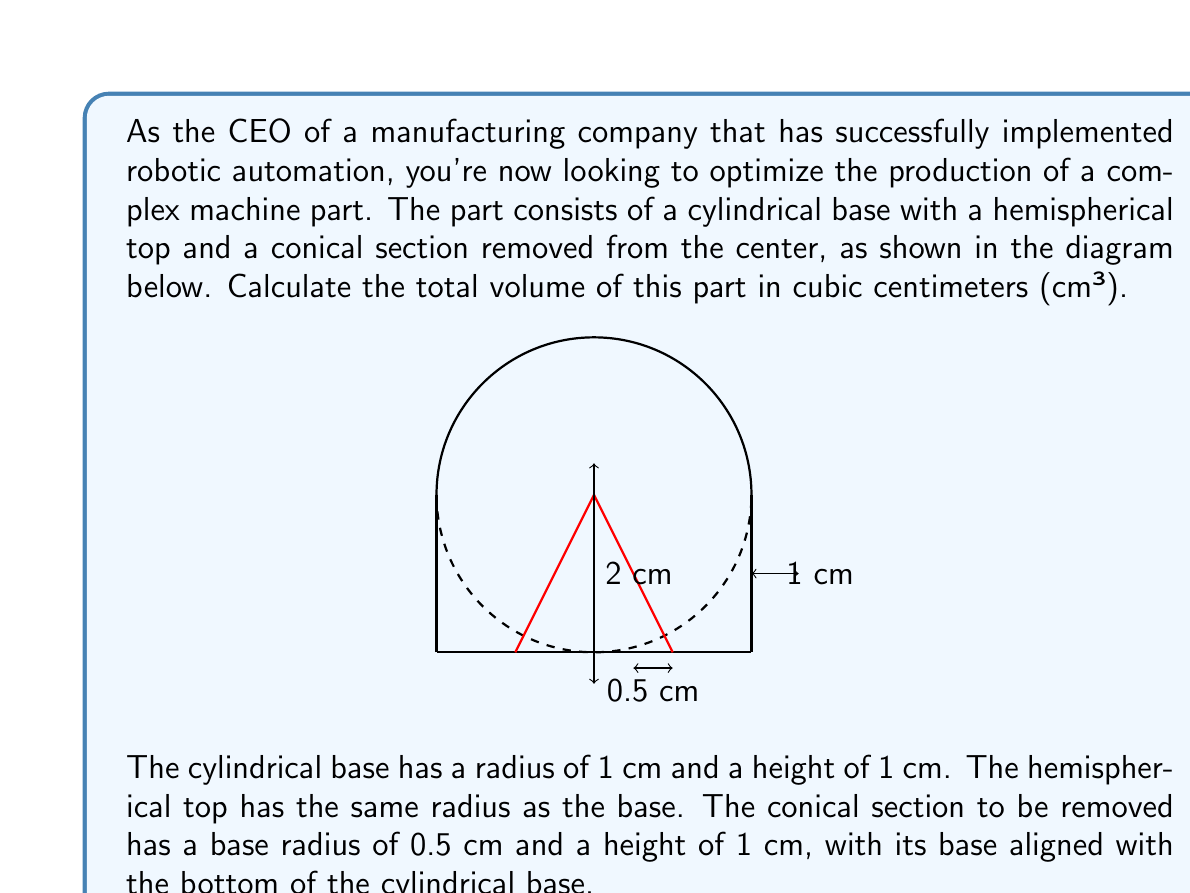Can you solve this math problem? Let's break this down step-by-step:

1) Volume of the cylindrical base:
   $$V_{cylinder} = \pi r^2 h = \pi \cdot 1^2 \cdot 1 = \pi \text{ cm}³$$

2) Volume of the hemispherical top:
   $$V_{hemisphere} = \frac{2}{3}\pi r^3 = \frac{2}{3}\pi \cdot 1^3 = \frac{2}{3}\pi \text{ cm}³$$

3) Volume of the conical section to be removed:
   $$V_{cone} = \frac{1}{3}\pi r^2 h = \frac{1}{3}\pi \cdot 0.5^2 \cdot 1 = \frac{1}{12}\pi \text{ cm}³$$

4) Total volume of the part:
   $$V_{total} = V_{cylinder} + V_{hemisphere} - V_{cone}$$
   $$V_{total} = \pi + \frac{2}{3}\pi - \frac{1}{12}\pi$$
   $$V_{total} = \frac{12\pi}{12} + \frac{8\pi}{12} - \frac{\pi}{12} = \frac{19\pi}{12} \text{ cm}³$$

5) To get a numerical value, we can use $\pi \approx 3.14159$:
   $$V_{total} \approx \frac{19 \cdot 3.14159}{12} \approx 4.9741 \text{ cm}³$$
Answer: $\frac{19\pi}{12} \text{ cm}³$ or approximately 4.9741 cm³ 